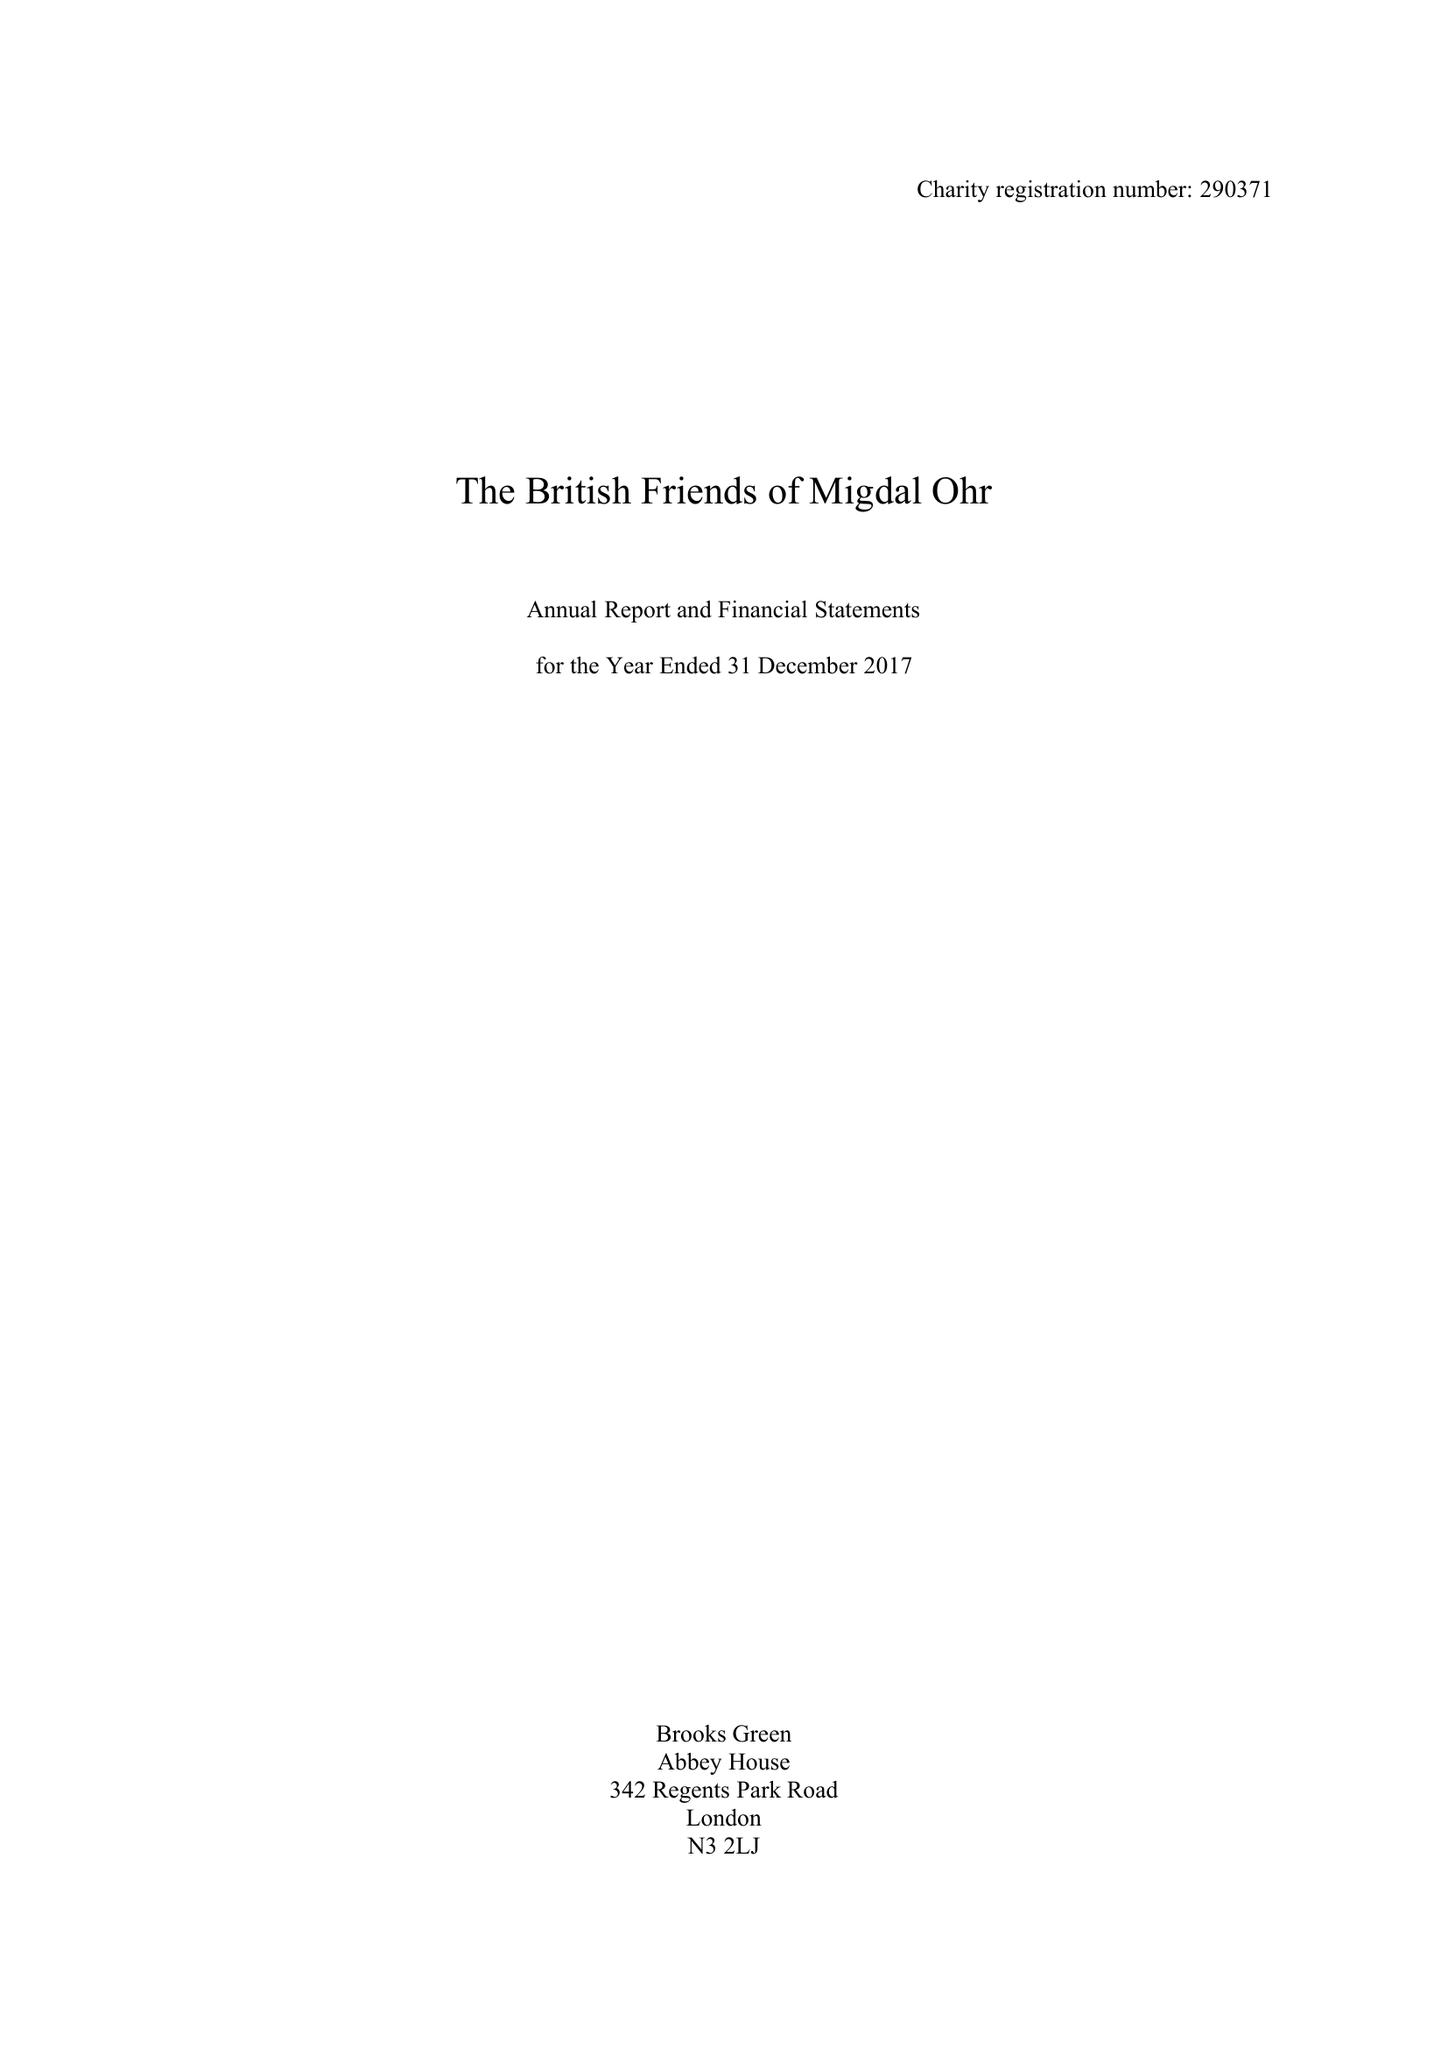What is the value for the income_annually_in_british_pounds?
Answer the question using a single word or phrase. 435827.00 